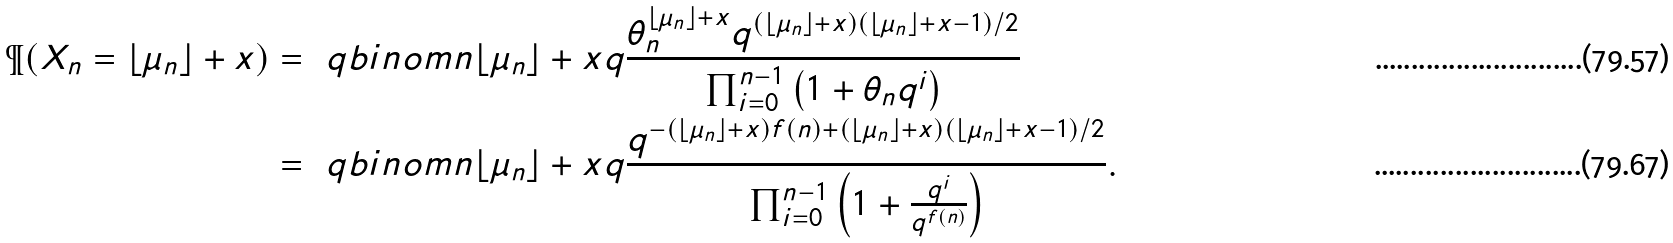Convert formula to latex. <formula><loc_0><loc_0><loc_500><loc_500>\P ( X _ { n } = \lfloor \mu _ { n } \rfloor + x ) & = \ q b i n o m { n } { \lfloor \mu _ { n } \rfloor + x } { q } \frac { \theta _ { n } ^ { \lfloor \mu _ { n } \rfloor + x } q ^ { ( \lfloor \mu _ { n } \rfloor + x ) ( \lfloor \mu _ { n } \rfloor + x - 1 ) / 2 } } { \prod _ { i = 0 } ^ { n - 1 } \left ( 1 + \theta _ { n } q ^ { i } \right ) } \\ & = \ q b i n o m { n } { \lfloor \mu _ { n } \rfloor + x } { q } \frac { q ^ { - ( \lfloor \mu _ { n } \rfloor + x ) f ( n ) + ( \lfloor \mu _ { n } \rfloor + x ) ( \lfloor \mu _ { n } \rfloor + x - 1 ) / 2 } } { \prod _ { i = 0 } ^ { n - 1 } \left ( 1 + \frac { q ^ { i } } { q ^ { f ( n ) } } \right ) } .</formula> 